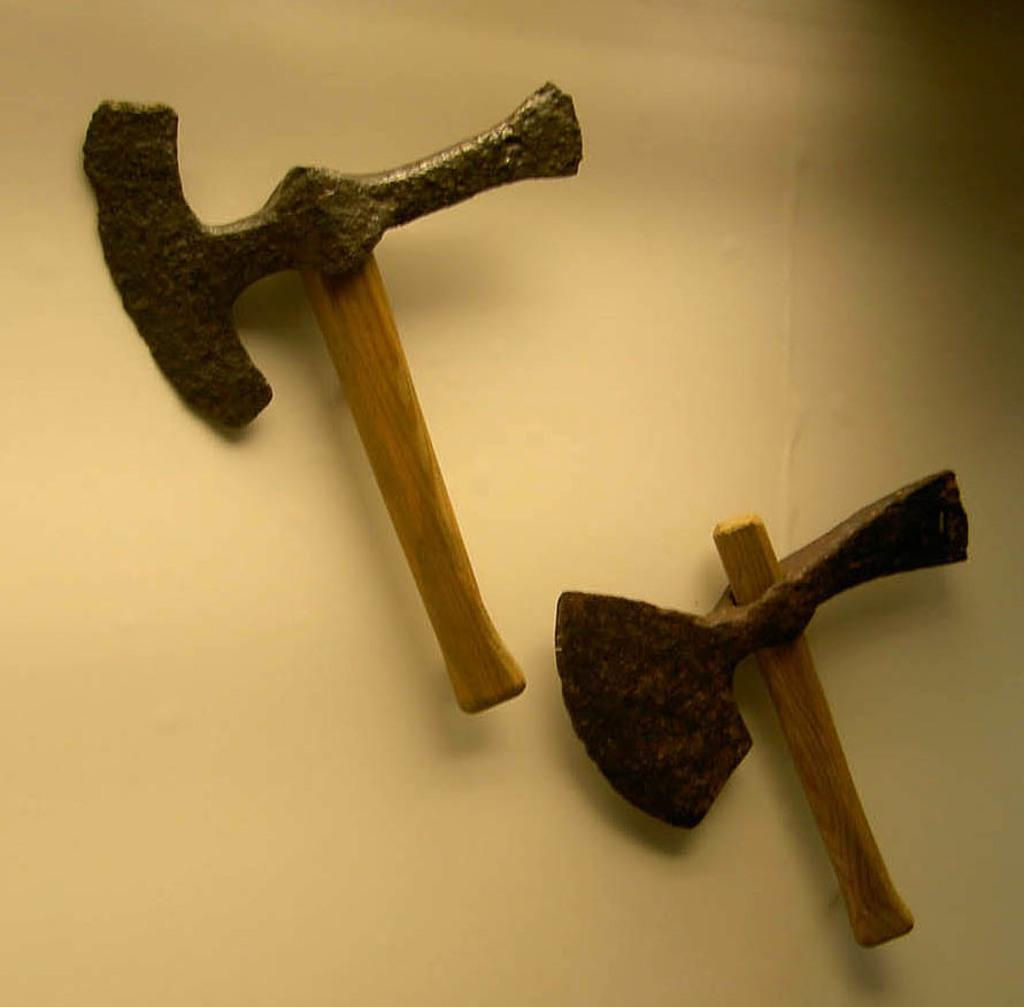What objects are in the image? There are two axes in the image. Where are the axes located? The axes are on the wall. What type of beast can be seen crawling on the cushion in the image? There is no beast or cushion present in the image; it only features two axes on the wall. 